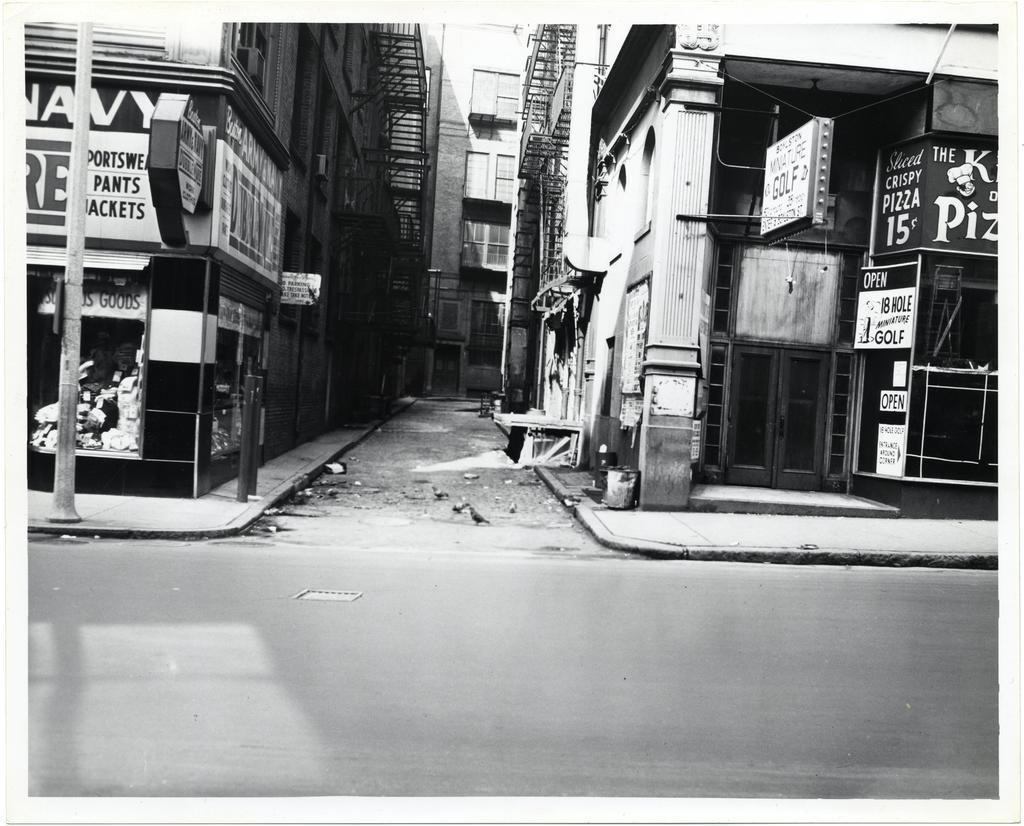Could you give a brief overview of what you see in this image? In the image we can see there are buildings and there are hoardings on the buildings. There is an iron pole on the footpath and there is road. The image is in black and white colour. 